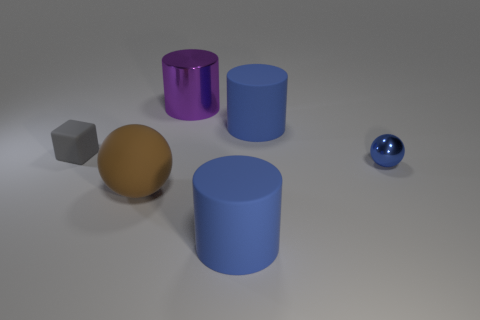Add 2 purple metallic cylinders. How many objects exist? 8 Subtract all cubes. How many objects are left? 5 Add 4 blue cylinders. How many blue cylinders are left? 6 Add 2 brown matte objects. How many brown matte objects exist? 3 Subtract 0 purple cubes. How many objects are left? 6 Subtract all big shiny things. Subtract all tiny blue objects. How many objects are left? 4 